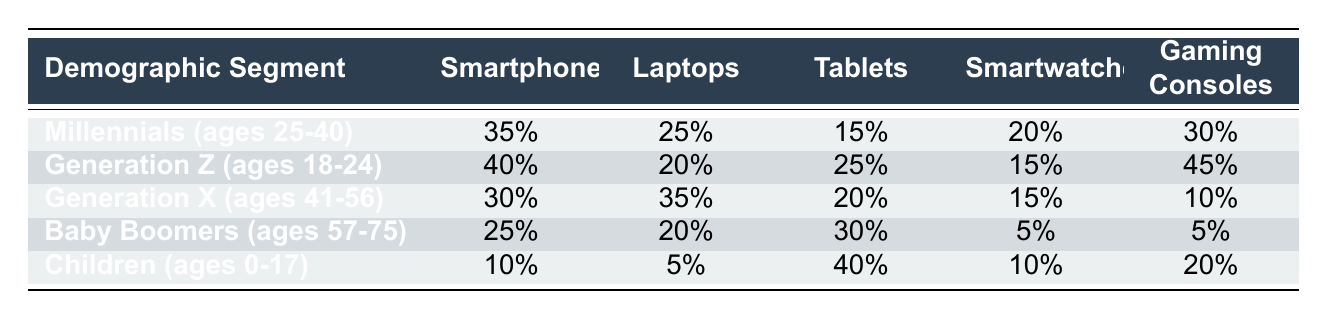What is the highest percentage of demand for smartphones among the demographic segments? The highest percentage for smartphones is found in the Generation Z segment at 40%. This is determined by comparing the smartphone percentages across all demographic segments listed: 35% for Millennials, 40% for Generation Z, 30% for Generation X, 25% for Baby Boomers, and 10% for Children.
Answer: 40% Which demographic segment has the lowest demand for laptops? The Children segment has the lowest demand for laptops, with only 5%. This is ascertained by looking at the laptops percentages: 25% for Millennials, 20% for Generation Z, 35% for Generation X, 20% for Baby Boomers, and 5% for Children.
Answer: 5% How much higher is the demand for gaming consoles in Generation Z compared to Baby Boomers? The demand for gaming consoles is 40% higher in Generation Z compared to Baby Boomers. Generation Z has a demand of 45%, while Baby Boomers have a demand of 5%. The difference is calculated as 45% - 5% = 40%.
Answer: 40% Is the demand for tablets in the Millennials segment greater than in the Baby Boomers segment? Yes, the demand for tablets in the Millennials segment is greater, with 15% compared to 30% for Baby Boomers. Therefore, this statement is false as Baby Boomers have a higher percentage for tablets.
Answer: No What is the total demand for smartwatches across all demographic segments? The total demand for smartwatches is calculated by adding the percentages from each demographic segment: 20% (Millennials) + 15% (Generation Z) + 15% (Generation X) + 5% (Baby Boomers) + 10% (Children) = 75%.
Answer: 75% Which demographic segment has the highest percentage for gaming consoles and what is that percentage? Generation Z has the highest percentage for gaming consoles at 45%. This is found by comparing the gaming console percentages across all segments: 30% (Millennials), 45% (Generation Z), 10% (Generation X), 5% (Baby Boomers), and 20% (Children), with Generation Z having the highest value.
Answer: 45% What is the average percentage demand for tablets among all demographic segments? To find the average for tablets, add the percentages: 15% (Millennials) + 25% (Generation Z) + 20% (Generation X) + 30% (Baby Boomers) + 40% (Children) = 140%. Then divide by 5 (the number of segments), yielding an average of 28%.
Answer: 28% Which two demographic segments have similar demands for smartphones? The Millennials and Generation X demographic segments have similar demands for smartphones, with percentages of 35% and 30%, respectively. While these percentages are close, they are not identical. This conclusion is reached by comparing the smartphone percentages across the segments.
Answer: Yes 